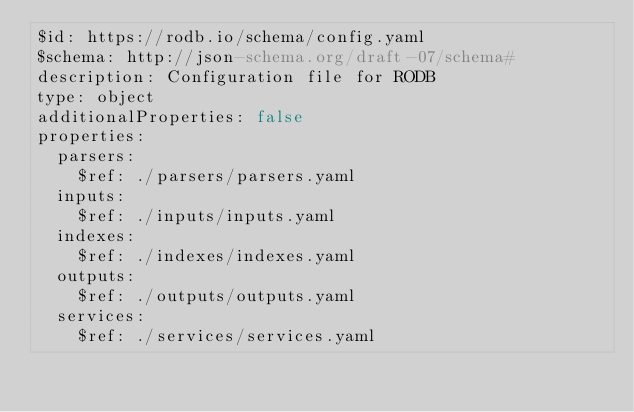Convert code to text. <code><loc_0><loc_0><loc_500><loc_500><_YAML_>$id: https://rodb.io/schema/config.yaml
$schema: http://json-schema.org/draft-07/schema#
description: Configuration file for RODB
type: object
additionalProperties: false
properties:
  parsers:
    $ref: ./parsers/parsers.yaml
  inputs:
    $ref: ./inputs/inputs.yaml
  indexes:
    $ref: ./indexes/indexes.yaml
  outputs:
    $ref: ./outputs/outputs.yaml
  services:
    $ref: ./services/services.yaml
</code> 